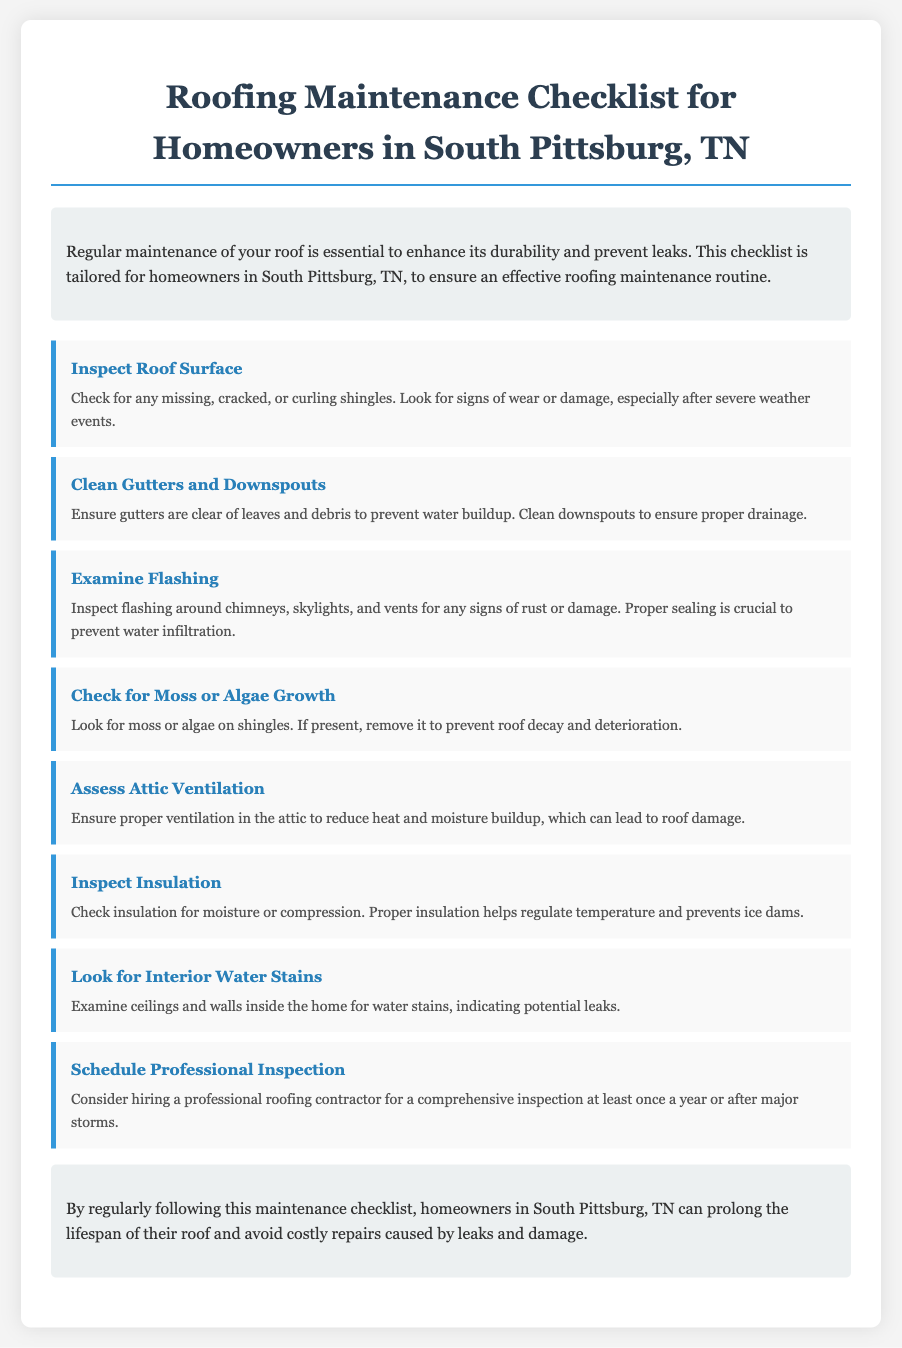what is the title of the document? The title of the document is provided at the top of the page.
Answer: Roofing Maintenance Checklist for Homeowners in South Pittsburg, TN how many main checklist items are listed? The document includes a list of main checklist items, visible in the checklist section.
Answer: 8 what do you need to check around chimneys and vents? The document mentions checking flashing around specific areas for damage.
Answer: Inspect flashing what is the purpose of attic ventilation? The document discusses the role of attic ventilation in relation to roof condition.
Answer: Reduce heat and moisture buildup what should you do if you find interior water stains? The document implies that interior stains indicate a problem that should be addressed.
Answer: Indicate potential leaks what activity is suggested after major storms? The document recommends a specific action to ensure roof integrity following severe weather.
Answer: Hire a professional inspection how often should you schedule a professional inspection? The document provides a frequency for professional inspections.
Answer: At least once a year what can moss or algae on shingles lead to? The document highlights the consequences of moss or algae presence.
Answer: Roof decay and deterioration 